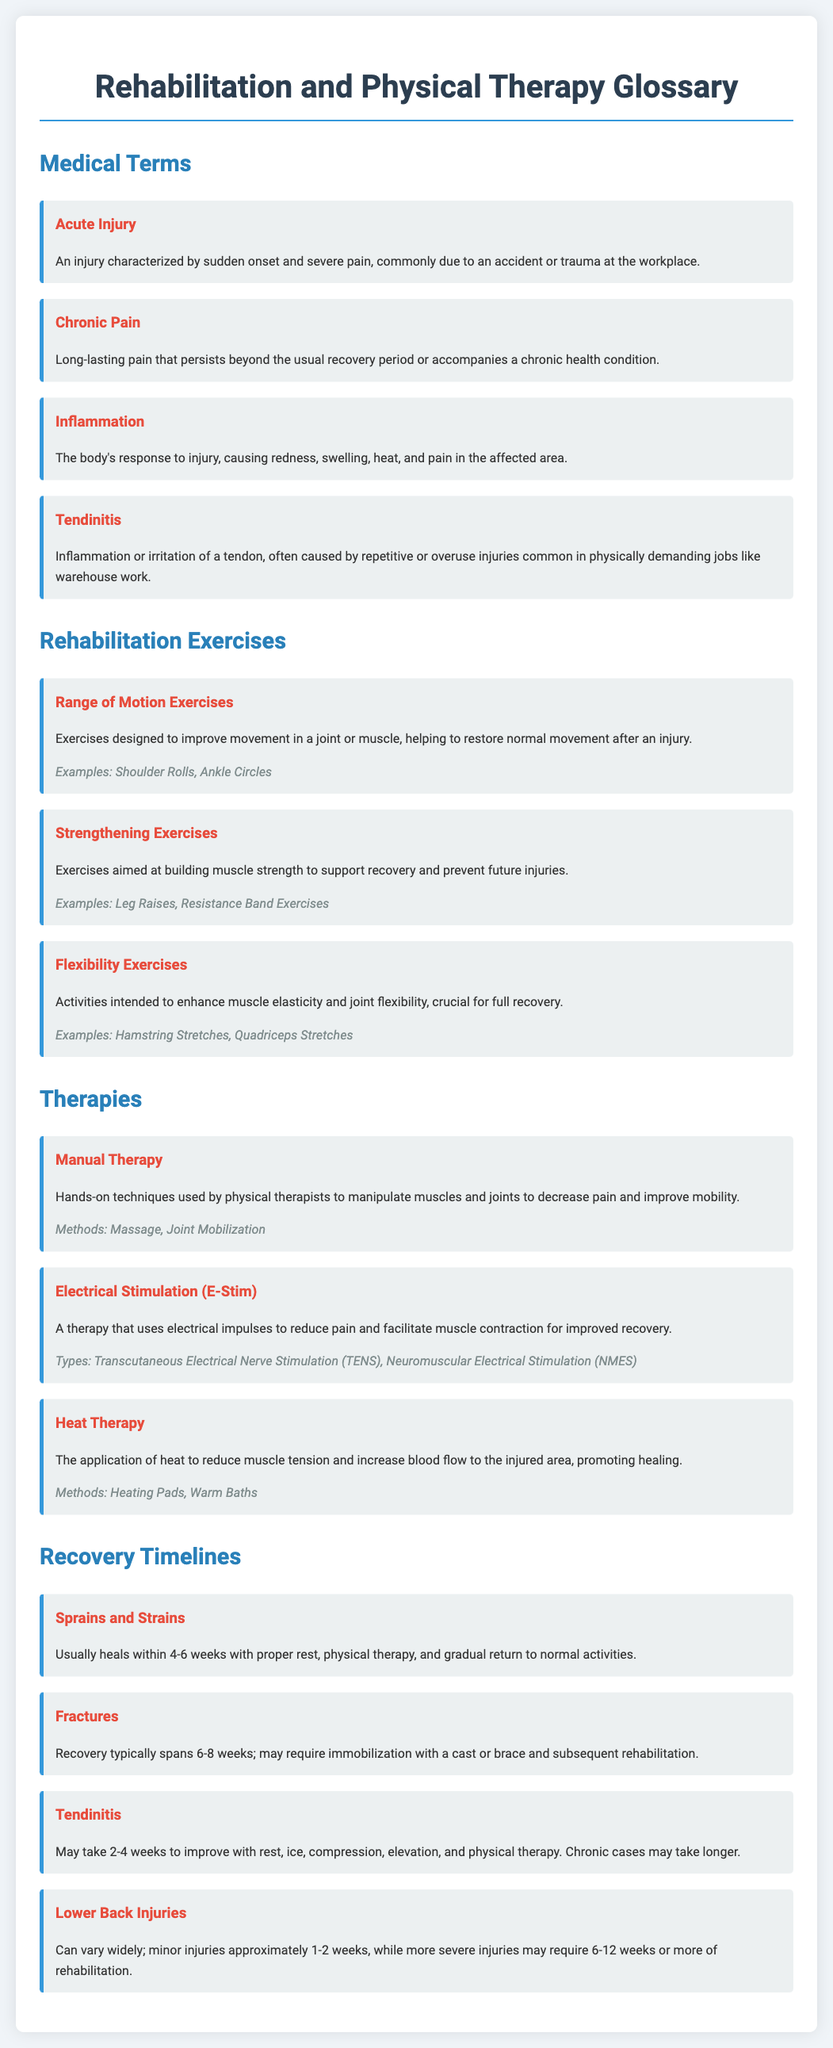What is an acute injury? An acute injury is characterized by sudden onset and severe pain, commonly due to an accident or trauma at the workplace.
Answer: Sudden onset and severe pain What are range of motion exercises? Range of motion exercises are designed to improve movement in a joint or muscle, helping to restore normal movement after an injury.
Answer: Improve movement What is the expected recovery time for sprains and strains? The expected recovery time for sprains and strains is usually 4-6 weeks with proper rest, physical therapy, and gradual return to normal activities.
Answer: 4-6 weeks What type of therapy uses electrical impulses? Electrical stimulation (E-Stim) uses electrical impulses to reduce pain and facilitate muscle contraction for improved recovery.
Answer: Electrical stimulation (E-Stim) What are examples of flexibility exercises? Examples of flexibility exercises include hamstring stretches and quadriceps stretches.
Answer: Hamstring stretches, Quadriceps stretches How long may tendinitis take to improve? Tendinitis may take 2-4 weeks to improve with rest, ice, compression, elevation, and physical therapy.
Answer: 2-4 weeks What is the method used in manual therapy? The method used in manual therapy includes massage and joint mobilization.
Answer: Massage, Joint Mobilization What does heat therapy aim to reduce? Heat therapy aims to reduce muscle tension and increase blood flow to the injured area.
Answer: Muscle tension How long does recovery from lower back injuries vary? Recovery from lower back injuries can vary widely, with minor injuries approximately 1-2 weeks and more severe injuries requiring 6-12 weeks or more.
Answer: 1-2 weeks to 6-12 weeks or more 